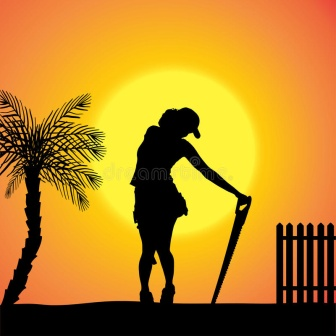What challenges might the figure face in tending to their duties? The silhouetted figure might face several challenges in their duties. One significant challenge could be the physical exhaustion from long hours of manual labor under the hot sun. There's also the possibility of dealing with unpredictable weather that could affect the soil and plant conditions. Additionally, the figure might have to contend with maintaining the health of the plants, protecting them from pests or diseases, and ensuring that the garden thrives despite these obstacles. Balancing the demands of the natural environment with the need for effective cultivation requires both stamina and a deep understanding of the ecosystem.  Only a single question: What inspired you to capture this image? This image was inspired by the timeless beauty of daily life and the serenity found in moments of labor during sunset. The contrast of the silhouetted figure against the radiant sun captures a powerful sense of solitude and reflection, embodying the quiet strength and dedication found in routine work. The scene is a tribute to those unseen moments of effort that contribute to the growth and beauty of our surroundings, illuminated by the enduring light of the setting sun. 